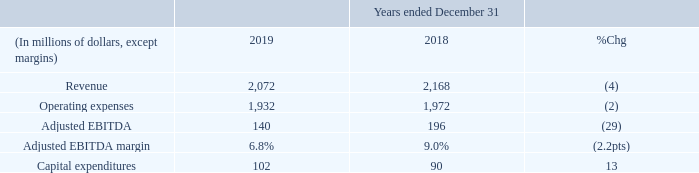MEDIA FINANCIAL RESULTS
REVENUE
Media revenue is earned from:
• advertising sales across its television, radio, and digital media properties; • subscriptions to televised and OTT products; • ticket sales, fund redistribution and other distributions from MLB, and concession sales; and • retail product sales.
The 4% decrease in revenue this year was a result of: • the sale of our publishing business in the second quarter of 2019; and • lower revenue at the Toronto Blue Jays, primarily as a result of a distribution from Major League Baseball in 2018; partially offset by • higher revenue generated by Sportsnet and TSC. Excluding the sale of our publishing business and the impact of the distribution from Major League Baseball last year, Media revenue would have increased by 1% this year.
OPERATING EXPENSES
We record Media operating expenses in four primary categories:
• the cost of broadcast content, including sports programming
and production;
• Toronto Blue Jays player compensation;
• the cost of retail products sold; and
• all other expenses involved in day-to-day operations.
The 2% decrease in operating expenses this year was a result of:
• lower Toronto Blue Jays player compensation; and
• lower publishing-related costs due to the sale of this business;
partially offset by
• higher programming costs; and
• higher cost of sales as a result of higher revenue at TSC.
ADJUSTED EBITDA
The 29% decrease in adjusted EBITDA this year was a result of the
revenue and expense changes described above. Excluding the
impact of the sale of our publishing business in the second quarter
of 2019 and the distribution from Major League Baseball last year,
adjusted EBITDA would have increased by 1% this year.
What are one of the components of Media Revenue? Advertising sales across its television, radio, and digital media properties. What were the revenues in 2019 and 2018?
Answer scale should be: million. 2,072, 2,168. What was the percentage decrease in Adjusted EBITDA from 2018 to 2019? 29%. What was the increase / (decrease) in revenue from 2018 to 2019?
Answer scale should be: million. 2,072 - 2,168
Answer: -96. What was the average Operating Expenses?
Answer scale should be: million. (1,932 + 1,972) / 2
Answer: 1952. What is the increase / (decrease) in Adjusted EBITDA from 2018 to 2019?
Answer scale should be: million. 140 - 196
Answer: -56. 